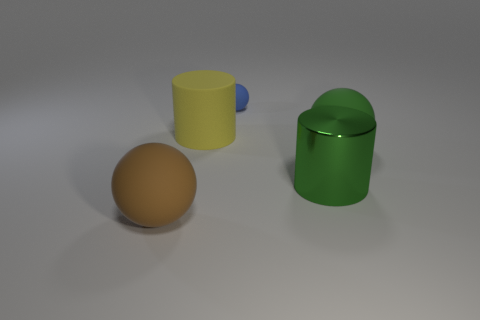Subtract all large spheres. How many spheres are left? 1 Subtract all brown spheres. How many spheres are left? 2 Add 3 large blue rubber objects. How many objects exist? 8 Subtract 2 spheres. How many spheres are left? 1 Subtract 0 brown cubes. How many objects are left? 5 Subtract all balls. How many objects are left? 2 Subtract all green balls. Subtract all red cylinders. How many balls are left? 2 Subtract all blue metal cylinders. Subtract all big brown things. How many objects are left? 4 Add 2 brown rubber objects. How many brown rubber objects are left? 3 Add 1 yellow things. How many yellow things exist? 2 